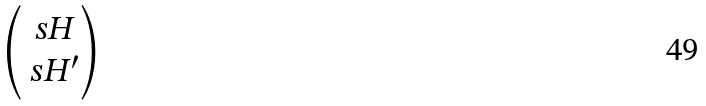<formula> <loc_0><loc_0><loc_500><loc_500>\begin{pmatrix} \ s H \\ \ s H ^ { \prime } \end{pmatrix}</formula> 